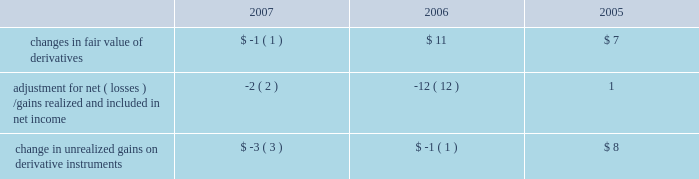Notes to consolidated financial statements ( continued ) note 6 2014shareholders 2019 equity ( continued ) the table summarizes activity in other comprehensive income related to derivatives , net of taxes , held by the company ( in millions ) : .
The tax effect related to the changes in fair value of derivatives was $ 1 million , $ ( 8 ) million , and $ ( 3 ) million for 2007 , 2006 , and 2005 , respectively .
The tax effect related to derivative gains/losses reclassified from other comprehensive income to net income was $ 2 million , $ 8 million , and $ ( 2 ) million for 2007 , 2006 , and 2005 , respectively .
Employee benefit plans 2003 employee stock plan the 2003 employee stock plan ( the 2018 20182003 plan 2019 2019 ) is a shareholder approved plan that provides for broad- based grants to employees , including executive officers .
Based on the terms of individual option grants , options granted under the 2003 plan generally expire 7 to 10 years after the grant date and generally become exercisable over a period of four years , based on continued employment , with either annual or quarterly vesting .
The 2003 plan permits the granting of incentive stock options , nonstatutory stock options , rsus , stock appreciation rights , stock purchase rights and performance-based awards .
During 2007 , the company 2019s shareholders approved an amendment to the 2003 plan to increase the number of shares authorized for issuance by 28 million shares .
1997 employee stock option plan in august 1997 , the company 2019s board of directors approved the 1997 employee stock option plan ( the 2018 20181997 plan 2019 2019 ) , a non-shareholder approved plan for grants of stock options to employees who are not officers of the company .
Based on the terms of individual option grants , options granted under the 1997 plan generally expire 7 to 10 years after the grant date and generally become exercisable over a period of four years , based on continued employment , with either annual or quarterly vesting .
In october 2003 , the company terminated the 1997 plan and no new options can be granted from this plan .
1997 director stock option plan in august 1997 , the company 2019s board of directors adopted a director stock option plan ( the 2018 2018director plan 2019 2019 ) for non-employee directors of the company , which was approved by shareholders in 1998 .
Pursuant to the director plan , the company 2019s non-employee directors are granted an option to acquire 30000 shares of common stock upon their initial election to the board ( 2018 2018initial options 2019 2019 ) .
The initial options vest and become exercisable in three equal annual installments on each of the first through third anniversaries of the grant date .
On the fourth anniversary of a non-employee director 2019s initial election to the board and on each subsequent anniversary thereafter , the director will be entitled to receive an option to acquire 10000 shares of common stock ( 2018 2018annual options 2019 2019 ) .
Annual options are fully vested and immediately exercisable on their date of grant .
Rule 10b5-1 trading plans certain of the company 2019s executive officers , including mr .
Timothy d .
Cook , mr .
Peter oppenheimer , mr .
Philip w .
Schiller , and dr .
Bertrand serlet , have entered into trading plans pursuant to .
What was the change in unrealized gains on derivative instruments between 2006 and 2007? 
Computations: (const_m1 - -3)
Answer: 2.0. 